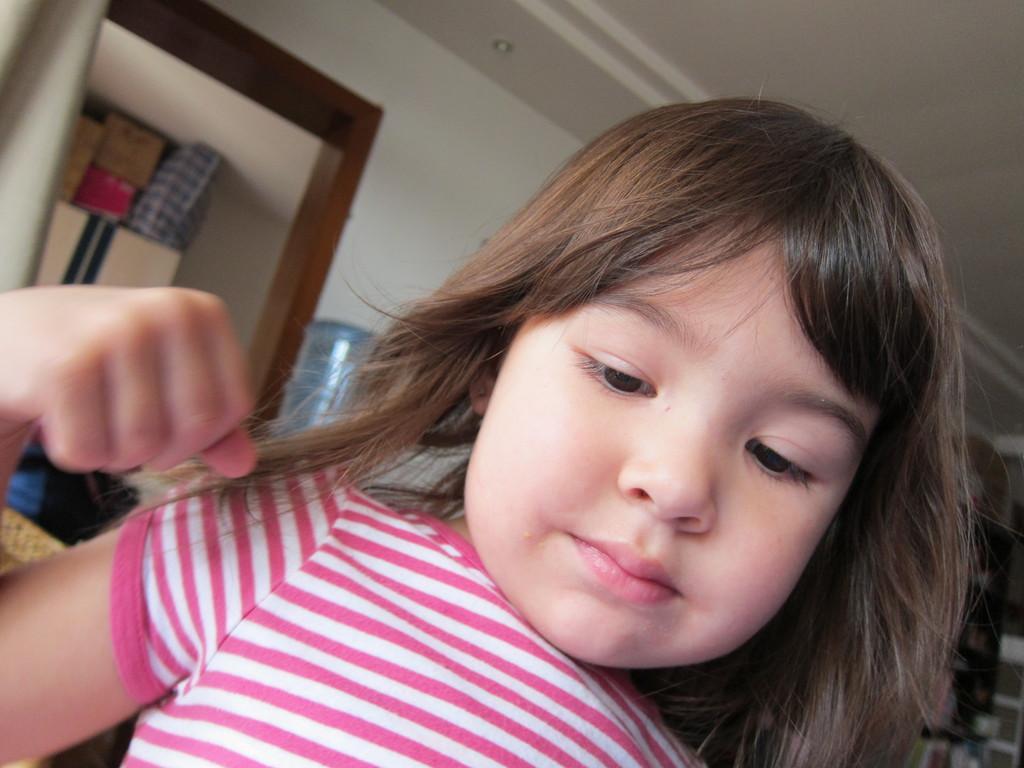Describe this image in one or two sentences. There is a small girl in the foreground area of the image, it seems like cupboards and other objects in the background. 